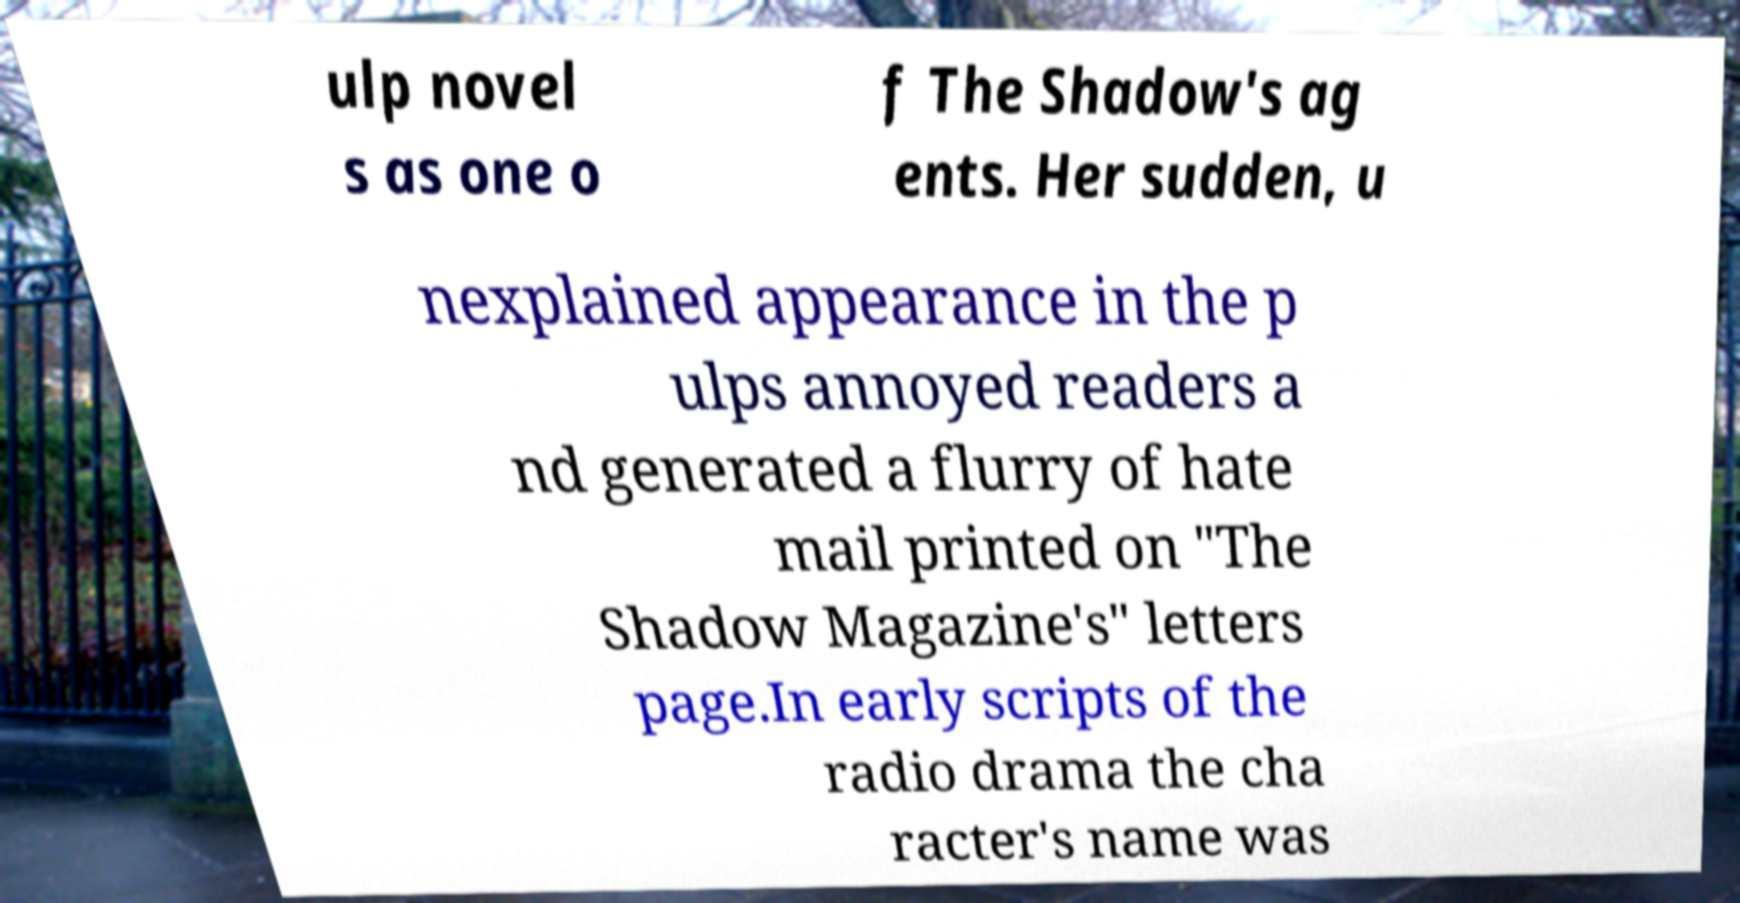Can you read and provide the text displayed in the image?This photo seems to have some interesting text. Can you extract and type it out for me? ulp novel s as one o f The Shadow's ag ents. Her sudden, u nexplained appearance in the p ulps annoyed readers a nd generated a flurry of hate mail printed on "The Shadow Magazine's" letters page.In early scripts of the radio drama the cha racter's name was 